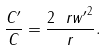Convert formula to latex. <formula><loc_0><loc_0><loc_500><loc_500>\frac { C ^ { \prime } } { C } = \frac { 2 { \ r w ^ { \prime } } ^ { 2 } } { r } .</formula> 